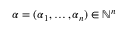Convert formula to latex. <formula><loc_0><loc_0><loc_500><loc_500>\alpha = ( \alpha _ { 1 } , \dots , \alpha _ { n } ) \in \mathbb { N } ^ { n }</formula> 